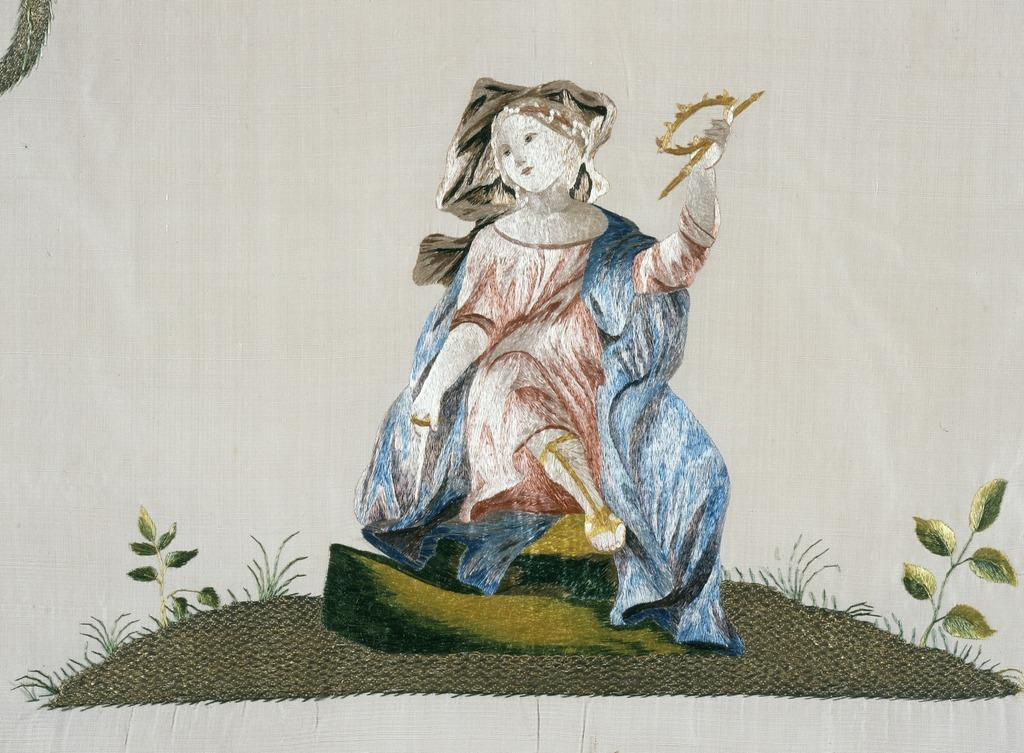What is the main subject of the image? There is an art piece in the image. What is the background or surface on which the art piece is placed? The art piece is on a white surface. What type of drum is being played in the image? There is no drum present in the image; it features an art piece on a white surface. How did the artist sustain a wound while creating the art piece in the image? There is no mention of a wound or the artist's process in the image, as it only shows an art piece on a white surface. 